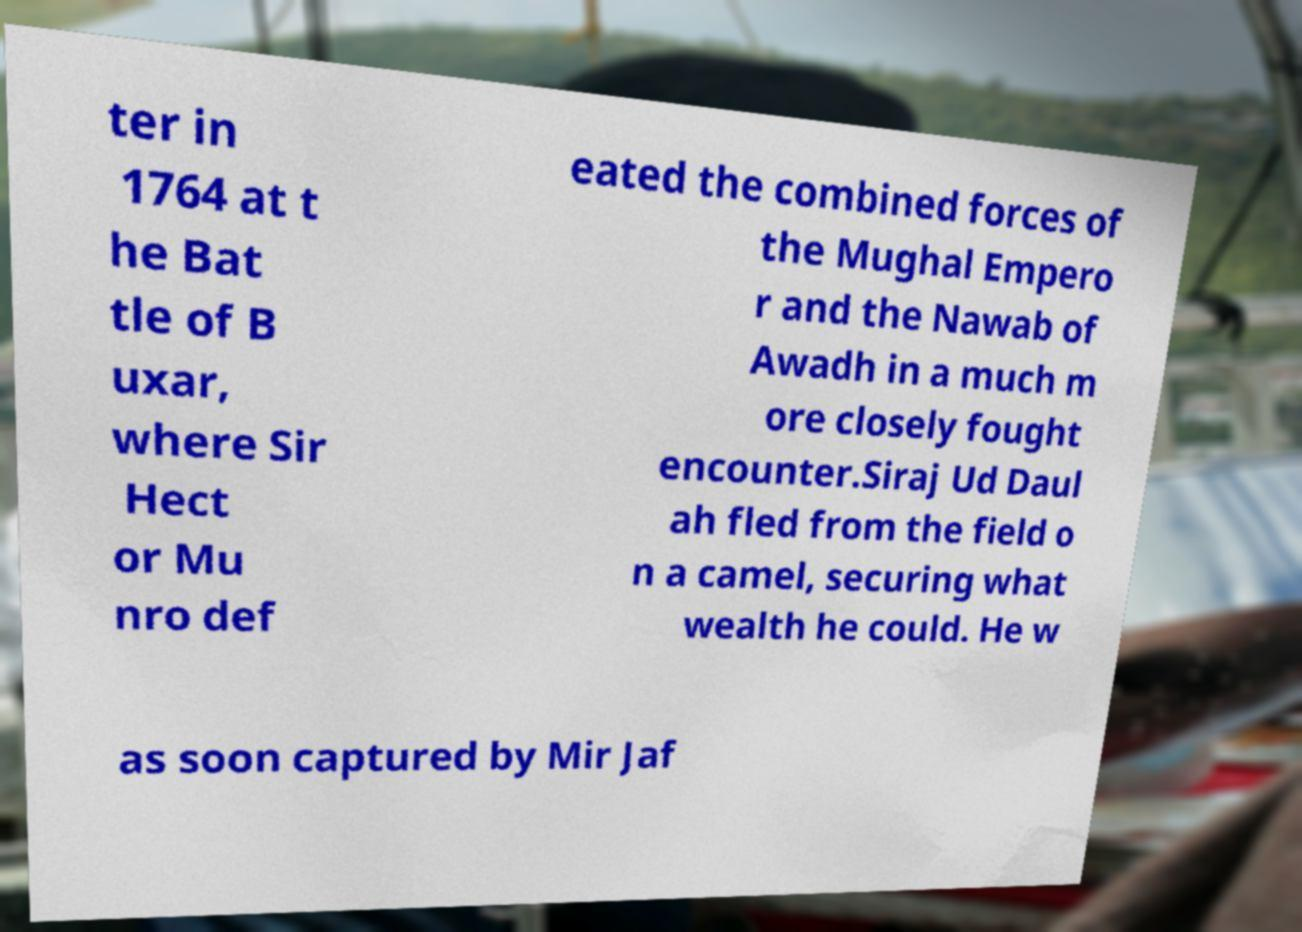Could you extract and type out the text from this image? ter in 1764 at t he Bat tle of B uxar, where Sir Hect or Mu nro def eated the combined forces of the Mughal Empero r and the Nawab of Awadh in a much m ore closely fought encounter.Siraj Ud Daul ah fled from the field o n a camel, securing what wealth he could. He w as soon captured by Mir Jaf 